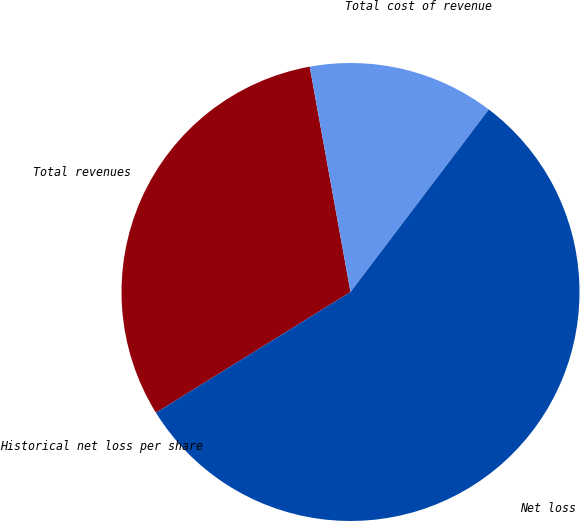Convert chart to OTSL. <chart><loc_0><loc_0><loc_500><loc_500><pie_chart><fcel>Total revenues<fcel>Total cost of revenue<fcel>Net loss<fcel>Historical net loss per share<nl><fcel>30.99%<fcel>13.17%<fcel>55.84%<fcel>0.0%<nl></chart> 